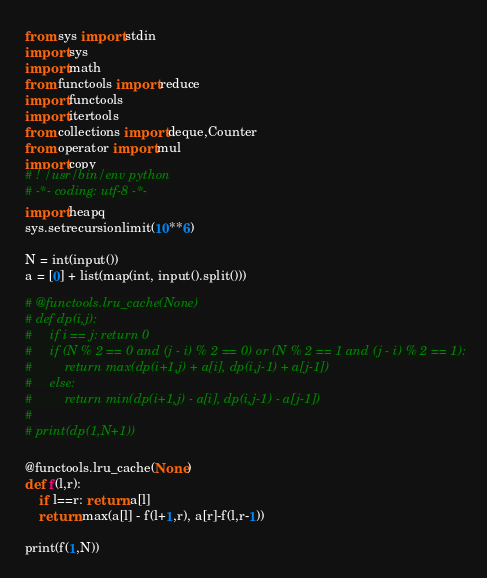<code> <loc_0><loc_0><loc_500><loc_500><_Python_>from sys import stdin
import sys
import math
from functools import reduce
import functools
import itertools
from collections import deque,Counter
from operator import mul
import copy
# ! /usr/bin/env python
# -*- coding: utf-8 -*-
import heapq
sys.setrecursionlimit(10**6)

N = int(input())
a = [0] + list(map(int, input().split()))

# @functools.lru_cache(None)
# def dp(i,j):
#     if i == j: return 0
#     if (N % 2 == 0 and (j - i) % 2 == 0) or (N % 2 == 1 and (j - i) % 2 == 1):
#         return max(dp(i+1,j) + a[i], dp(i,j-1) + a[j-1])
#     else:
#         return min(dp(i+1,j) - a[i], dp(i,j-1) - a[j-1])
#
# print(dp(1,N+1))

@functools.lru_cache(None)
def f(l,r):
    if l==r: return a[l]
    return max(a[l] - f(l+1,r), a[r]-f(l,r-1))

print(f(1,N))</code> 